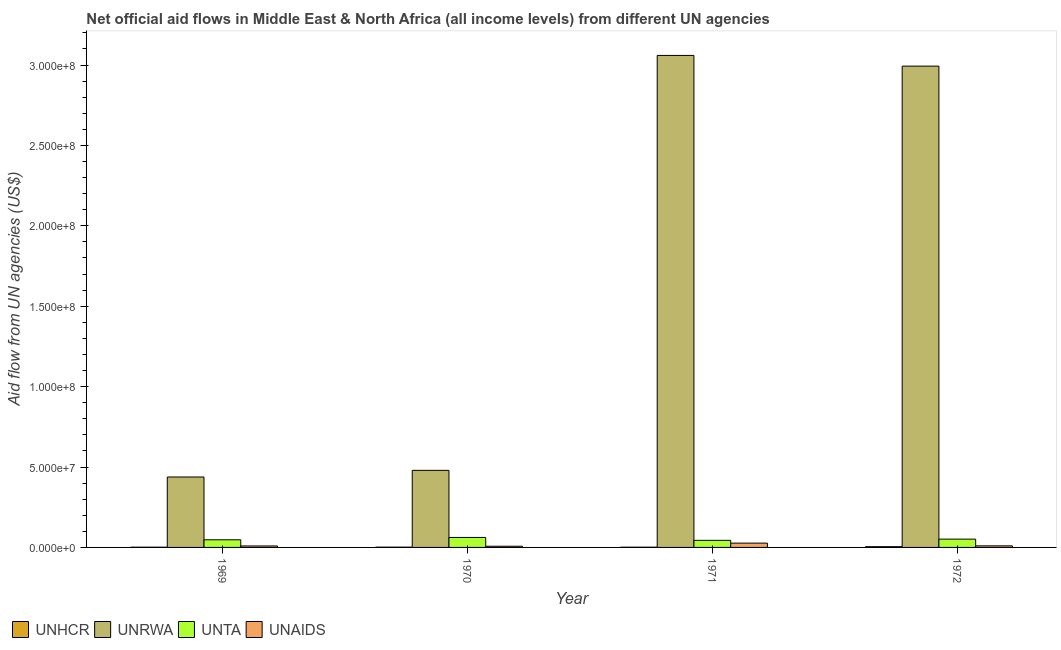How many different coloured bars are there?
Provide a succinct answer. 4. How many groups of bars are there?
Offer a terse response. 4. Are the number of bars per tick equal to the number of legend labels?
Ensure brevity in your answer.  Yes. Are the number of bars on each tick of the X-axis equal?
Your answer should be very brief. Yes. How many bars are there on the 4th tick from the right?
Keep it short and to the point. 4. What is the label of the 4th group of bars from the left?
Your response must be concise. 1972. In how many cases, is the number of bars for a given year not equal to the number of legend labels?
Make the answer very short. 0. What is the amount of aid given by unaids in 1969?
Your answer should be very brief. 9.10e+05. Across all years, what is the maximum amount of aid given by unaids?
Your answer should be very brief. 2.68e+06. Across all years, what is the minimum amount of aid given by unta?
Your response must be concise. 4.41e+06. What is the total amount of aid given by unrwa in the graph?
Keep it short and to the point. 6.97e+08. What is the difference between the amount of aid given by unta in 1971 and that in 1972?
Your response must be concise. -7.50e+05. What is the difference between the amount of aid given by unhcr in 1969 and the amount of aid given by unta in 1972?
Keep it short and to the point. -3.20e+05. What is the average amount of aid given by unta per year?
Your answer should be compact. 5.13e+06. In how many years, is the amount of aid given by unrwa greater than 250000000 US$?
Keep it short and to the point. 2. What is the ratio of the amount of aid given by unaids in 1971 to that in 1972?
Provide a short and direct response. 2.73. Is the amount of aid given by unaids in 1969 less than that in 1970?
Make the answer very short. No. What is the difference between the highest and the second highest amount of aid given by unaids?
Your answer should be very brief. 1.70e+06. What is the difference between the highest and the lowest amount of aid given by unta?
Keep it short and to the point. 1.80e+06. Is the sum of the amount of aid given by unhcr in 1969 and 1970 greater than the maximum amount of aid given by unta across all years?
Give a very brief answer. No. What does the 4th bar from the left in 1971 represents?
Provide a short and direct response. UNAIDS. What does the 2nd bar from the right in 1970 represents?
Offer a terse response. UNTA. Are all the bars in the graph horizontal?
Your response must be concise. No. What is the difference between two consecutive major ticks on the Y-axis?
Your answer should be compact. 5.00e+07. Does the graph contain grids?
Keep it short and to the point. No. How many legend labels are there?
Your response must be concise. 4. How are the legend labels stacked?
Give a very brief answer. Horizontal. What is the title of the graph?
Keep it short and to the point. Net official aid flows in Middle East & North Africa (all income levels) from different UN agencies. Does "Fish species" appear as one of the legend labels in the graph?
Your answer should be very brief. No. What is the label or title of the X-axis?
Keep it short and to the point. Year. What is the label or title of the Y-axis?
Your response must be concise. Aid flow from UN agencies (US$). What is the Aid flow from UN agencies (US$) of UNRWA in 1969?
Provide a succinct answer. 4.38e+07. What is the Aid flow from UN agencies (US$) of UNTA in 1969?
Your answer should be very brief. 4.75e+06. What is the Aid flow from UN agencies (US$) of UNAIDS in 1969?
Ensure brevity in your answer.  9.10e+05. What is the Aid flow from UN agencies (US$) of UNRWA in 1970?
Offer a terse response. 4.79e+07. What is the Aid flow from UN agencies (US$) in UNTA in 1970?
Offer a terse response. 6.21e+06. What is the Aid flow from UN agencies (US$) in UNAIDS in 1970?
Provide a succinct answer. 7.40e+05. What is the Aid flow from UN agencies (US$) in UNHCR in 1971?
Make the answer very short. 1.40e+05. What is the Aid flow from UN agencies (US$) in UNRWA in 1971?
Give a very brief answer. 3.06e+08. What is the Aid flow from UN agencies (US$) of UNTA in 1971?
Offer a very short reply. 4.41e+06. What is the Aid flow from UN agencies (US$) in UNAIDS in 1971?
Your answer should be very brief. 2.68e+06. What is the Aid flow from UN agencies (US$) of UNRWA in 1972?
Keep it short and to the point. 2.99e+08. What is the Aid flow from UN agencies (US$) in UNTA in 1972?
Provide a succinct answer. 5.16e+06. What is the Aid flow from UN agencies (US$) in UNAIDS in 1972?
Your response must be concise. 9.80e+05. Across all years, what is the maximum Aid flow from UN agencies (US$) in UNHCR?
Your answer should be very brief. 4.60e+05. Across all years, what is the maximum Aid flow from UN agencies (US$) in UNRWA?
Your answer should be very brief. 3.06e+08. Across all years, what is the maximum Aid flow from UN agencies (US$) in UNTA?
Your answer should be very brief. 6.21e+06. Across all years, what is the maximum Aid flow from UN agencies (US$) of UNAIDS?
Ensure brevity in your answer.  2.68e+06. Across all years, what is the minimum Aid flow from UN agencies (US$) in UNHCR?
Your answer should be very brief. 1.40e+05. Across all years, what is the minimum Aid flow from UN agencies (US$) in UNRWA?
Your response must be concise. 4.38e+07. Across all years, what is the minimum Aid flow from UN agencies (US$) of UNTA?
Provide a succinct answer. 4.41e+06. Across all years, what is the minimum Aid flow from UN agencies (US$) of UNAIDS?
Make the answer very short. 7.40e+05. What is the total Aid flow from UN agencies (US$) in UNHCR in the graph?
Your response must be concise. 9.10e+05. What is the total Aid flow from UN agencies (US$) in UNRWA in the graph?
Offer a very short reply. 6.97e+08. What is the total Aid flow from UN agencies (US$) in UNTA in the graph?
Provide a succinct answer. 2.05e+07. What is the total Aid flow from UN agencies (US$) of UNAIDS in the graph?
Offer a very short reply. 5.31e+06. What is the difference between the Aid flow from UN agencies (US$) of UNRWA in 1969 and that in 1970?
Your answer should be very brief. -4.13e+06. What is the difference between the Aid flow from UN agencies (US$) of UNTA in 1969 and that in 1970?
Your answer should be very brief. -1.46e+06. What is the difference between the Aid flow from UN agencies (US$) of UNAIDS in 1969 and that in 1970?
Make the answer very short. 1.70e+05. What is the difference between the Aid flow from UN agencies (US$) in UNHCR in 1969 and that in 1971?
Keep it short and to the point. 0. What is the difference between the Aid flow from UN agencies (US$) of UNRWA in 1969 and that in 1971?
Give a very brief answer. -2.62e+08. What is the difference between the Aid flow from UN agencies (US$) of UNAIDS in 1969 and that in 1971?
Give a very brief answer. -1.77e+06. What is the difference between the Aid flow from UN agencies (US$) in UNHCR in 1969 and that in 1972?
Keep it short and to the point. -3.20e+05. What is the difference between the Aid flow from UN agencies (US$) of UNRWA in 1969 and that in 1972?
Provide a succinct answer. -2.56e+08. What is the difference between the Aid flow from UN agencies (US$) of UNTA in 1969 and that in 1972?
Ensure brevity in your answer.  -4.10e+05. What is the difference between the Aid flow from UN agencies (US$) of UNRWA in 1970 and that in 1971?
Provide a succinct answer. -2.58e+08. What is the difference between the Aid flow from UN agencies (US$) of UNTA in 1970 and that in 1971?
Your answer should be compact. 1.80e+06. What is the difference between the Aid flow from UN agencies (US$) in UNAIDS in 1970 and that in 1971?
Keep it short and to the point. -1.94e+06. What is the difference between the Aid flow from UN agencies (US$) in UNRWA in 1970 and that in 1972?
Make the answer very short. -2.51e+08. What is the difference between the Aid flow from UN agencies (US$) of UNTA in 1970 and that in 1972?
Make the answer very short. 1.05e+06. What is the difference between the Aid flow from UN agencies (US$) of UNAIDS in 1970 and that in 1972?
Provide a short and direct response. -2.40e+05. What is the difference between the Aid flow from UN agencies (US$) in UNHCR in 1971 and that in 1972?
Make the answer very short. -3.20e+05. What is the difference between the Aid flow from UN agencies (US$) in UNRWA in 1971 and that in 1972?
Your answer should be compact. 6.65e+06. What is the difference between the Aid flow from UN agencies (US$) of UNTA in 1971 and that in 1972?
Offer a terse response. -7.50e+05. What is the difference between the Aid flow from UN agencies (US$) of UNAIDS in 1971 and that in 1972?
Give a very brief answer. 1.70e+06. What is the difference between the Aid flow from UN agencies (US$) of UNHCR in 1969 and the Aid flow from UN agencies (US$) of UNRWA in 1970?
Offer a terse response. -4.78e+07. What is the difference between the Aid flow from UN agencies (US$) of UNHCR in 1969 and the Aid flow from UN agencies (US$) of UNTA in 1970?
Provide a succinct answer. -6.07e+06. What is the difference between the Aid flow from UN agencies (US$) of UNHCR in 1969 and the Aid flow from UN agencies (US$) of UNAIDS in 1970?
Offer a very short reply. -6.00e+05. What is the difference between the Aid flow from UN agencies (US$) of UNRWA in 1969 and the Aid flow from UN agencies (US$) of UNTA in 1970?
Provide a succinct answer. 3.76e+07. What is the difference between the Aid flow from UN agencies (US$) of UNRWA in 1969 and the Aid flow from UN agencies (US$) of UNAIDS in 1970?
Provide a succinct answer. 4.31e+07. What is the difference between the Aid flow from UN agencies (US$) of UNTA in 1969 and the Aid flow from UN agencies (US$) of UNAIDS in 1970?
Offer a terse response. 4.01e+06. What is the difference between the Aid flow from UN agencies (US$) in UNHCR in 1969 and the Aid flow from UN agencies (US$) in UNRWA in 1971?
Ensure brevity in your answer.  -3.06e+08. What is the difference between the Aid flow from UN agencies (US$) of UNHCR in 1969 and the Aid flow from UN agencies (US$) of UNTA in 1971?
Offer a very short reply. -4.27e+06. What is the difference between the Aid flow from UN agencies (US$) of UNHCR in 1969 and the Aid flow from UN agencies (US$) of UNAIDS in 1971?
Your response must be concise. -2.54e+06. What is the difference between the Aid flow from UN agencies (US$) of UNRWA in 1969 and the Aid flow from UN agencies (US$) of UNTA in 1971?
Offer a very short reply. 3.94e+07. What is the difference between the Aid flow from UN agencies (US$) in UNRWA in 1969 and the Aid flow from UN agencies (US$) in UNAIDS in 1971?
Make the answer very short. 4.11e+07. What is the difference between the Aid flow from UN agencies (US$) in UNTA in 1969 and the Aid flow from UN agencies (US$) in UNAIDS in 1971?
Ensure brevity in your answer.  2.07e+06. What is the difference between the Aid flow from UN agencies (US$) in UNHCR in 1969 and the Aid flow from UN agencies (US$) in UNRWA in 1972?
Provide a succinct answer. -2.99e+08. What is the difference between the Aid flow from UN agencies (US$) of UNHCR in 1969 and the Aid flow from UN agencies (US$) of UNTA in 1972?
Ensure brevity in your answer.  -5.02e+06. What is the difference between the Aid flow from UN agencies (US$) of UNHCR in 1969 and the Aid flow from UN agencies (US$) of UNAIDS in 1972?
Your response must be concise. -8.40e+05. What is the difference between the Aid flow from UN agencies (US$) of UNRWA in 1969 and the Aid flow from UN agencies (US$) of UNTA in 1972?
Ensure brevity in your answer.  3.86e+07. What is the difference between the Aid flow from UN agencies (US$) of UNRWA in 1969 and the Aid flow from UN agencies (US$) of UNAIDS in 1972?
Provide a short and direct response. 4.28e+07. What is the difference between the Aid flow from UN agencies (US$) in UNTA in 1969 and the Aid flow from UN agencies (US$) in UNAIDS in 1972?
Your response must be concise. 3.77e+06. What is the difference between the Aid flow from UN agencies (US$) in UNHCR in 1970 and the Aid flow from UN agencies (US$) in UNRWA in 1971?
Make the answer very short. -3.06e+08. What is the difference between the Aid flow from UN agencies (US$) of UNHCR in 1970 and the Aid flow from UN agencies (US$) of UNTA in 1971?
Your response must be concise. -4.24e+06. What is the difference between the Aid flow from UN agencies (US$) in UNHCR in 1970 and the Aid flow from UN agencies (US$) in UNAIDS in 1971?
Offer a terse response. -2.51e+06. What is the difference between the Aid flow from UN agencies (US$) of UNRWA in 1970 and the Aid flow from UN agencies (US$) of UNTA in 1971?
Give a very brief answer. 4.35e+07. What is the difference between the Aid flow from UN agencies (US$) of UNRWA in 1970 and the Aid flow from UN agencies (US$) of UNAIDS in 1971?
Give a very brief answer. 4.52e+07. What is the difference between the Aid flow from UN agencies (US$) of UNTA in 1970 and the Aid flow from UN agencies (US$) of UNAIDS in 1971?
Offer a very short reply. 3.53e+06. What is the difference between the Aid flow from UN agencies (US$) in UNHCR in 1970 and the Aid flow from UN agencies (US$) in UNRWA in 1972?
Keep it short and to the point. -2.99e+08. What is the difference between the Aid flow from UN agencies (US$) of UNHCR in 1970 and the Aid flow from UN agencies (US$) of UNTA in 1972?
Keep it short and to the point. -4.99e+06. What is the difference between the Aid flow from UN agencies (US$) of UNHCR in 1970 and the Aid flow from UN agencies (US$) of UNAIDS in 1972?
Your response must be concise. -8.10e+05. What is the difference between the Aid flow from UN agencies (US$) in UNRWA in 1970 and the Aid flow from UN agencies (US$) in UNTA in 1972?
Your response must be concise. 4.28e+07. What is the difference between the Aid flow from UN agencies (US$) in UNRWA in 1970 and the Aid flow from UN agencies (US$) in UNAIDS in 1972?
Provide a short and direct response. 4.70e+07. What is the difference between the Aid flow from UN agencies (US$) of UNTA in 1970 and the Aid flow from UN agencies (US$) of UNAIDS in 1972?
Offer a terse response. 5.23e+06. What is the difference between the Aid flow from UN agencies (US$) of UNHCR in 1971 and the Aid flow from UN agencies (US$) of UNRWA in 1972?
Your answer should be very brief. -2.99e+08. What is the difference between the Aid flow from UN agencies (US$) of UNHCR in 1971 and the Aid flow from UN agencies (US$) of UNTA in 1972?
Give a very brief answer. -5.02e+06. What is the difference between the Aid flow from UN agencies (US$) of UNHCR in 1971 and the Aid flow from UN agencies (US$) of UNAIDS in 1972?
Provide a short and direct response. -8.40e+05. What is the difference between the Aid flow from UN agencies (US$) in UNRWA in 1971 and the Aid flow from UN agencies (US$) in UNTA in 1972?
Give a very brief answer. 3.01e+08. What is the difference between the Aid flow from UN agencies (US$) in UNRWA in 1971 and the Aid flow from UN agencies (US$) in UNAIDS in 1972?
Provide a short and direct response. 3.05e+08. What is the difference between the Aid flow from UN agencies (US$) of UNTA in 1971 and the Aid flow from UN agencies (US$) of UNAIDS in 1972?
Offer a terse response. 3.43e+06. What is the average Aid flow from UN agencies (US$) in UNHCR per year?
Keep it short and to the point. 2.28e+05. What is the average Aid flow from UN agencies (US$) of UNRWA per year?
Ensure brevity in your answer.  1.74e+08. What is the average Aid flow from UN agencies (US$) of UNTA per year?
Provide a succinct answer. 5.13e+06. What is the average Aid flow from UN agencies (US$) in UNAIDS per year?
Give a very brief answer. 1.33e+06. In the year 1969, what is the difference between the Aid flow from UN agencies (US$) in UNHCR and Aid flow from UN agencies (US$) in UNRWA?
Your answer should be very brief. -4.37e+07. In the year 1969, what is the difference between the Aid flow from UN agencies (US$) in UNHCR and Aid flow from UN agencies (US$) in UNTA?
Your answer should be compact. -4.61e+06. In the year 1969, what is the difference between the Aid flow from UN agencies (US$) of UNHCR and Aid flow from UN agencies (US$) of UNAIDS?
Make the answer very short. -7.70e+05. In the year 1969, what is the difference between the Aid flow from UN agencies (US$) in UNRWA and Aid flow from UN agencies (US$) in UNTA?
Provide a succinct answer. 3.90e+07. In the year 1969, what is the difference between the Aid flow from UN agencies (US$) in UNRWA and Aid flow from UN agencies (US$) in UNAIDS?
Provide a short and direct response. 4.29e+07. In the year 1969, what is the difference between the Aid flow from UN agencies (US$) of UNTA and Aid flow from UN agencies (US$) of UNAIDS?
Offer a terse response. 3.84e+06. In the year 1970, what is the difference between the Aid flow from UN agencies (US$) in UNHCR and Aid flow from UN agencies (US$) in UNRWA?
Give a very brief answer. -4.78e+07. In the year 1970, what is the difference between the Aid flow from UN agencies (US$) of UNHCR and Aid flow from UN agencies (US$) of UNTA?
Provide a succinct answer. -6.04e+06. In the year 1970, what is the difference between the Aid flow from UN agencies (US$) of UNHCR and Aid flow from UN agencies (US$) of UNAIDS?
Your answer should be very brief. -5.70e+05. In the year 1970, what is the difference between the Aid flow from UN agencies (US$) of UNRWA and Aid flow from UN agencies (US$) of UNTA?
Give a very brief answer. 4.17e+07. In the year 1970, what is the difference between the Aid flow from UN agencies (US$) of UNRWA and Aid flow from UN agencies (US$) of UNAIDS?
Provide a succinct answer. 4.72e+07. In the year 1970, what is the difference between the Aid flow from UN agencies (US$) of UNTA and Aid flow from UN agencies (US$) of UNAIDS?
Ensure brevity in your answer.  5.47e+06. In the year 1971, what is the difference between the Aid flow from UN agencies (US$) of UNHCR and Aid flow from UN agencies (US$) of UNRWA?
Keep it short and to the point. -3.06e+08. In the year 1971, what is the difference between the Aid flow from UN agencies (US$) in UNHCR and Aid flow from UN agencies (US$) in UNTA?
Your answer should be very brief. -4.27e+06. In the year 1971, what is the difference between the Aid flow from UN agencies (US$) of UNHCR and Aid flow from UN agencies (US$) of UNAIDS?
Provide a short and direct response. -2.54e+06. In the year 1971, what is the difference between the Aid flow from UN agencies (US$) of UNRWA and Aid flow from UN agencies (US$) of UNTA?
Make the answer very short. 3.02e+08. In the year 1971, what is the difference between the Aid flow from UN agencies (US$) in UNRWA and Aid flow from UN agencies (US$) in UNAIDS?
Your answer should be compact. 3.03e+08. In the year 1971, what is the difference between the Aid flow from UN agencies (US$) of UNTA and Aid flow from UN agencies (US$) of UNAIDS?
Ensure brevity in your answer.  1.73e+06. In the year 1972, what is the difference between the Aid flow from UN agencies (US$) in UNHCR and Aid flow from UN agencies (US$) in UNRWA?
Ensure brevity in your answer.  -2.99e+08. In the year 1972, what is the difference between the Aid flow from UN agencies (US$) of UNHCR and Aid flow from UN agencies (US$) of UNTA?
Ensure brevity in your answer.  -4.70e+06. In the year 1972, what is the difference between the Aid flow from UN agencies (US$) in UNHCR and Aid flow from UN agencies (US$) in UNAIDS?
Keep it short and to the point. -5.20e+05. In the year 1972, what is the difference between the Aid flow from UN agencies (US$) in UNRWA and Aid flow from UN agencies (US$) in UNTA?
Make the answer very short. 2.94e+08. In the year 1972, what is the difference between the Aid flow from UN agencies (US$) of UNRWA and Aid flow from UN agencies (US$) of UNAIDS?
Ensure brevity in your answer.  2.98e+08. In the year 1972, what is the difference between the Aid flow from UN agencies (US$) in UNTA and Aid flow from UN agencies (US$) in UNAIDS?
Provide a succinct answer. 4.18e+06. What is the ratio of the Aid flow from UN agencies (US$) of UNHCR in 1969 to that in 1970?
Provide a short and direct response. 0.82. What is the ratio of the Aid flow from UN agencies (US$) of UNRWA in 1969 to that in 1970?
Make the answer very short. 0.91. What is the ratio of the Aid flow from UN agencies (US$) in UNTA in 1969 to that in 1970?
Your response must be concise. 0.76. What is the ratio of the Aid flow from UN agencies (US$) in UNAIDS in 1969 to that in 1970?
Provide a short and direct response. 1.23. What is the ratio of the Aid flow from UN agencies (US$) of UNHCR in 1969 to that in 1971?
Offer a terse response. 1. What is the ratio of the Aid flow from UN agencies (US$) of UNRWA in 1969 to that in 1971?
Provide a succinct answer. 0.14. What is the ratio of the Aid flow from UN agencies (US$) in UNTA in 1969 to that in 1971?
Offer a terse response. 1.08. What is the ratio of the Aid flow from UN agencies (US$) in UNAIDS in 1969 to that in 1971?
Your answer should be very brief. 0.34. What is the ratio of the Aid flow from UN agencies (US$) of UNHCR in 1969 to that in 1972?
Keep it short and to the point. 0.3. What is the ratio of the Aid flow from UN agencies (US$) of UNRWA in 1969 to that in 1972?
Give a very brief answer. 0.15. What is the ratio of the Aid flow from UN agencies (US$) in UNTA in 1969 to that in 1972?
Your answer should be very brief. 0.92. What is the ratio of the Aid flow from UN agencies (US$) of UNHCR in 1970 to that in 1971?
Provide a succinct answer. 1.21. What is the ratio of the Aid flow from UN agencies (US$) of UNRWA in 1970 to that in 1971?
Provide a succinct answer. 0.16. What is the ratio of the Aid flow from UN agencies (US$) in UNTA in 1970 to that in 1971?
Ensure brevity in your answer.  1.41. What is the ratio of the Aid flow from UN agencies (US$) of UNAIDS in 1970 to that in 1971?
Give a very brief answer. 0.28. What is the ratio of the Aid flow from UN agencies (US$) of UNHCR in 1970 to that in 1972?
Your answer should be very brief. 0.37. What is the ratio of the Aid flow from UN agencies (US$) of UNRWA in 1970 to that in 1972?
Give a very brief answer. 0.16. What is the ratio of the Aid flow from UN agencies (US$) of UNTA in 1970 to that in 1972?
Your answer should be compact. 1.2. What is the ratio of the Aid flow from UN agencies (US$) in UNAIDS in 1970 to that in 1972?
Your answer should be very brief. 0.76. What is the ratio of the Aid flow from UN agencies (US$) in UNHCR in 1971 to that in 1972?
Provide a succinct answer. 0.3. What is the ratio of the Aid flow from UN agencies (US$) of UNRWA in 1971 to that in 1972?
Ensure brevity in your answer.  1.02. What is the ratio of the Aid flow from UN agencies (US$) of UNTA in 1971 to that in 1972?
Your answer should be very brief. 0.85. What is the ratio of the Aid flow from UN agencies (US$) of UNAIDS in 1971 to that in 1972?
Offer a very short reply. 2.73. What is the difference between the highest and the second highest Aid flow from UN agencies (US$) of UNHCR?
Offer a very short reply. 2.90e+05. What is the difference between the highest and the second highest Aid flow from UN agencies (US$) in UNRWA?
Make the answer very short. 6.65e+06. What is the difference between the highest and the second highest Aid flow from UN agencies (US$) in UNTA?
Your answer should be very brief. 1.05e+06. What is the difference between the highest and the second highest Aid flow from UN agencies (US$) in UNAIDS?
Give a very brief answer. 1.70e+06. What is the difference between the highest and the lowest Aid flow from UN agencies (US$) in UNRWA?
Provide a short and direct response. 2.62e+08. What is the difference between the highest and the lowest Aid flow from UN agencies (US$) in UNTA?
Make the answer very short. 1.80e+06. What is the difference between the highest and the lowest Aid flow from UN agencies (US$) of UNAIDS?
Your answer should be compact. 1.94e+06. 